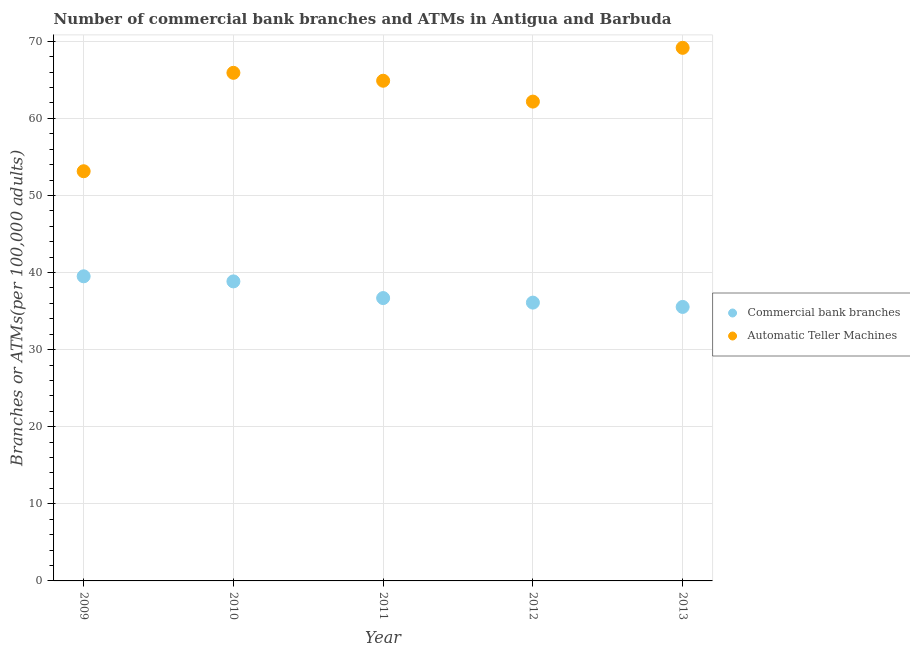How many different coloured dotlines are there?
Give a very brief answer. 2. Is the number of dotlines equal to the number of legend labels?
Offer a terse response. Yes. What is the number of commercal bank branches in 2010?
Offer a very short reply. 38.85. Across all years, what is the maximum number of atms?
Provide a short and direct response. 69.15. Across all years, what is the minimum number of atms?
Your answer should be very brief. 53.14. In which year was the number of atms maximum?
Your answer should be very brief. 2013. In which year was the number of atms minimum?
Your answer should be compact. 2009. What is the total number of commercal bank branches in the graph?
Keep it short and to the point. 186.69. What is the difference between the number of atms in 2009 and that in 2010?
Give a very brief answer. -12.76. What is the difference between the number of atms in 2011 and the number of commercal bank branches in 2010?
Make the answer very short. 26.03. What is the average number of atms per year?
Provide a short and direct response. 63.05. In the year 2013, what is the difference between the number of atms and number of commercal bank branches?
Your response must be concise. 33.61. What is the ratio of the number of commercal bank branches in 2011 to that in 2012?
Make the answer very short. 1.02. Is the difference between the number of atms in 2012 and 2013 greater than the difference between the number of commercal bank branches in 2012 and 2013?
Your response must be concise. No. What is the difference between the highest and the second highest number of atms?
Keep it short and to the point. 3.24. What is the difference between the highest and the lowest number of commercal bank branches?
Give a very brief answer. 3.97. Is the number of commercal bank branches strictly greater than the number of atms over the years?
Offer a terse response. No. Is the number of atms strictly less than the number of commercal bank branches over the years?
Offer a very short reply. No. How many dotlines are there?
Provide a succinct answer. 2. How many years are there in the graph?
Your answer should be compact. 5. Does the graph contain any zero values?
Give a very brief answer. No. What is the title of the graph?
Ensure brevity in your answer.  Number of commercial bank branches and ATMs in Antigua and Barbuda. Does "Arms exports" appear as one of the legend labels in the graph?
Make the answer very short. No. What is the label or title of the X-axis?
Make the answer very short. Year. What is the label or title of the Y-axis?
Offer a very short reply. Branches or ATMs(per 100,0 adults). What is the Branches or ATMs(per 100,000 adults) in Commercial bank branches in 2009?
Keep it short and to the point. 39.51. What is the Branches or ATMs(per 100,000 adults) of Automatic Teller Machines in 2009?
Your answer should be very brief. 53.14. What is the Branches or ATMs(per 100,000 adults) of Commercial bank branches in 2010?
Give a very brief answer. 38.85. What is the Branches or ATMs(per 100,000 adults) in Automatic Teller Machines in 2010?
Make the answer very short. 65.91. What is the Branches or ATMs(per 100,000 adults) in Commercial bank branches in 2011?
Keep it short and to the point. 36.69. What is the Branches or ATMs(per 100,000 adults) in Automatic Teller Machines in 2011?
Your answer should be compact. 64.88. What is the Branches or ATMs(per 100,000 adults) in Commercial bank branches in 2012?
Your answer should be very brief. 36.1. What is the Branches or ATMs(per 100,000 adults) of Automatic Teller Machines in 2012?
Provide a short and direct response. 62.17. What is the Branches or ATMs(per 100,000 adults) of Commercial bank branches in 2013?
Keep it short and to the point. 35.54. What is the Branches or ATMs(per 100,000 adults) in Automatic Teller Machines in 2013?
Ensure brevity in your answer.  69.15. Across all years, what is the maximum Branches or ATMs(per 100,000 adults) in Commercial bank branches?
Offer a very short reply. 39.51. Across all years, what is the maximum Branches or ATMs(per 100,000 adults) of Automatic Teller Machines?
Your response must be concise. 69.15. Across all years, what is the minimum Branches or ATMs(per 100,000 adults) in Commercial bank branches?
Ensure brevity in your answer.  35.54. Across all years, what is the minimum Branches or ATMs(per 100,000 adults) of Automatic Teller Machines?
Your response must be concise. 53.14. What is the total Branches or ATMs(per 100,000 adults) in Commercial bank branches in the graph?
Provide a succinct answer. 186.69. What is the total Branches or ATMs(per 100,000 adults) of Automatic Teller Machines in the graph?
Give a very brief answer. 315.24. What is the difference between the Branches or ATMs(per 100,000 adults) of Commercial bank branches in 2009 and that in 2010?
Provide a succinct answer. 0.66. What is the difference between the Branches or ATMs(per 100,000 adults) of Automatic Teller Machines in 2009 and that in 2010?
Your answer should be compact. -12.76. What is the difference between the Branches or ATMs(per 100,000 adults) in Commercial bank branches in 2009 and that in 2011?
Provide a succinct answer. 2.82. What is the difference between the Branches or ATMs(per 100,000 adults) in Automatic Teller Machines in 2009 and that in 2011?
Offer a terse response. -11.74. What is the difference between the Branches or ATMs(per 100,000 adults) in Commercial bank branches in 2009 and that in 2012?
Your answer should be compact. 3.41. What is the difference between the Branches or ATMs(per 100,000 adults) in Automatic Teller Machines in 2009 and that in 2012?
Provide a succinct answer. -9.03. What is the difference between the Branches or ATMs(per 100,000 adults) in Commercial bank branches in 2009 and that in 2013?
Offer a very short reply. 3.97. What is the difference between the Branches or ATMs(per 100,000 adults) in Automatic Teller Machines in 2009 and that in 2013?
Give a very brief answer. -16.01. What is the difference between the Branches or ATMs(per 100,000 adults) in Commercial bank branches in 2010 and that in 2011?
Make the answer very short. 2.16. What is the difference between the Branches or ATMs(per 100,000 adults) in Automatic Teller Machines in 2010 and that in 2011?
Provide a short and direct response. 1.03. What is the difference between the Branches or ATMs(per 100,000 adults) of Commercial bank branches in 2010 and that in 2012?
Offer a terse response. 2.75. What is the difference between the Branches or ATMs(per 100,000 adults) in Automatic Teller Machines in 2010 and that in 2012?
Keep it short and to the point. 3.73. What is the difference between the Branches or ATMs(per 100,000 adults) in Commercial bank branches in 2010 and that in 2013?
Offer a terse response. 3.31. What is the difference between the Branches or ATMs(per 100,000 adults) of Automatic Teller Machines in 2010 and that in 2013?
Offer a very short reply. -3.24. What is the difference between the Branches or ATMs(per 100,000 adults) in Commercial bank branches in 2011 and that in 2012?
Your answer should be very brief. 0.59. What is the difference between the Branches or ATMs(per 100,000 adults) in Automatic Teller Machines in 2011 and that in 2012?
Keep it short and to the point. 2.71. What is the difference between the Branches or ATMs(per 100,000 adults) in Commercial bank branches in 2011 and that in 2013?
Your response must be concise. 1.15. What is the difference between the Branches or ATMs(per 100,000 adults) of Automatic Teller Machines in 2011 and that in 2013?
Offer a terse response. -4.27. What is the difference between the Branches or ATMs(per 100,000 adults) of Commercial bank branches in 2012 and that in 2013?
Provide a succinct answer. 0.56. What is the difference between the Branches or ATMs(per 100,000 adults) in Automatic Teller Machines in 2012 and that in 2013?
Your answer should be very brief. -6.97. What is the difference between the Branches or ATMs(per 100,000 adults) of Commercial bank branches in 2009 and the Branches or ATMs(per 100,000 adults) of Automatic Teller Machines in 2010?
Your answer should be compact. -26.39. What is the difference between the Branches or ATMs(per 100,000 adults) in Commercial bank branches in 2009 and the Branches or ATMs(per 100,000 adults) in Automatic Teller Machines in 2011?
Offer a terse response. -25.37. What is the difference between the Branches or ATMs(per 100,000 adults) in Commercial bank branches in 2009 and the Branches or ATMs(per 100,000 adults) in Automatic Teller Machines in 2012?
Your answer should be very brief. -22.66. What is the difference between the Branches or ATMs(per 100,000 adults) in Commercial bank branches in 2009 and the Branches or ATMs(per 100,000 adults) in Automatic Teller Machines in 2013?
Provide a short and direct response. -29.64. What is the difference between the Branches or ATMs(per 100,000 adults) of Commercial bank branches in 2010 and the Branches or ATMs(per 100,000 adults) of Automatic Teller Machines in 2011?
Your response must be concise. -26.03. What is the difference between the Branches or ATMs(per 100,000 adults) in Commercial bank branches in 2010 and the Branches or ATMs(per 100,000 adults) in Automatic Teller Machines in 2012?
Your answer should be compact. -23.32. What is the difference between the Branches or ATMs(per 100,000 adults) in Commercial bank branches in 2010 and the Branches or ATMs(per 100,000 adults) in Automatic Teller Machines in 2013?
Your response must be concise. -30.3. What is the difference between the Branches or ATMs(per 100,000 adults) in Commercial bank branches in 2011 and the Branches or ATMs(per 100,000 adults) in Automatic Teller Machines in 2012?
Provide a short and direct response. -25.48. What is the difference between the Branches or ATMs(per 100,000 adults) of Commercial bank branches in 2011 and the Branches or ATMs(per 100,000 adults) of Automatic Teller Machines in 2013?
Offer a very short reply. -32.46. What is the difference between the Branches or ATMs(per 100,000 adults) in Commercial bank branches in 2012 and the Branches or ATMs(per 100,000 adults) in Automatic Teller Machines in 2013?
Your response must be concise. -33.05. What is the average Branches or ATMs(per 100,000 adults) of Commercial bank branches per year?
Keep it short and to the point. 37.34. What is the average Branches or ATMs(per 100,000 adults) in Automatic Teller Machines per year?
Give a very brief answer. 63.05. In the year 2009, what is the difference between the Branches or ATMs(per 100,000 adults) of Commercial bank branches and Branches or ATMs(per 100,000 adults) of Automatic Teller Machines?
Offer a very short reply. -13.63. In the year 2010, what is the difference between the Branches or ATMs(per 100,000 adults) in Commercial bank branches and Branches or ATMs(per 100,000 adults) in Automatic Teller Machines?
Keep it short and to the point. -27.05. In the year 2011, what is the difference between the Branches or ATMs(per 100,000 adults) in Commercial bank branches and Branches or ATMs(per 100,000 adults) in Automatic Teller Machines?
Make the answer very short. -28.19. In the year 2012, what is the difference between the Branches or ATMs(per 100,000 adults) in Commercial bank branches and Branches or ATMs(per 100,000 adults) in Automatic Teller Machines?
Your answer should be compact. -26.07. In the year 2013, what is the difference between the Branches or ATMs(per 100,000 adults) in Commercial bank branches and Branches or ATMs(per 100,000 adults) in Automatic Teller Machines?
Offer a terse response. -33.61. What is the ratio of the Branches or ATMs(per 100,000 adults) in Automatic Teller Machines in 2009 to that in 2010?
Make the answer very short. 0.81. What is the ratio of the Branches or ATMs(per 100,000 adults) of Automatic Teller Machines in 2009 to that in 2011?
Keep it short and to the point. 0.82. What is the ratio of the Branches or ATMs(per 100,000 adults) of Commercial bank branches in 2009 to that in 2012?
Your response must be concise. 1.09. What is the ratio of the Branches or ATMs(per 100,000 adults) of Automatic Teller Machines in 2009 to that in 2012?
Give a very brief answer. 0.85. What is the ratio of the Branches or ATMs(per 100,000 adults) in Commercial bank branches in 2009 to that in 2013?
Make the answer very short. 1.11. What is the ratio of the Branches or ATMs(per 100,000 adults) of Automatic Teller Machines in 2009 to that in 2013?
Provide a succinct answer. 0.77. What is the ratio of the Branches or ATMs(per 100,000 adults) of Commercial bank branches in 2010 to that in 2011?
Your answer should be compact. 1.06. What is the ratio of the Branches or ATMs(per 100,000 adults) of Automatic Teller Machines in 2010 to that in 2011?
Make the answer very short. 1.02. What is the ratio of the Branches or ATMs(per 100,000 adults) in Commercial bank branches in 2010 to that in 2012?
Offer a terse response. 1.08. What is the ratio of the Branches or ATMs(per 100,000 adults) of Automatic Teller Machines in 2010 to that in 2012?
Make the answer very short. 1.06. What is the ratio of the Branches or ATMs(per 100,000 adults) of Commercial bank branches in 2010 to that in 2013?
Ensure brevity in your answer.  1.09. What is the ratio of the Branches or ATMs(per 100,000 adults) of Automatic Teller Machines in 2010 to that in 2013?
Your answer should be compact. 0.95. What is the ratio of the Branches or ATMs(per 100,000 adults) in Commercial bank branches in 2011 to that in 2012?
Ensure brevity in your answer.  1.02. What is the ratio of the Branches or ATMs(per 100,000 adults) in Automatic Teller Machines in 2011 to that in 2012?
Keep it short and to the point. 1.04. What is the ratio of the Branches or ATMs(per 100,000 adults) of Commercial bank branches in 2011 to that in 2013?
Make the answer very short. 1.03. What is the ratio of the Branches or ATMs(per 100,000 adults) in Automatic Teller Machines in 2011 to that in 2013?
Your answer should be compact. 0.94. What is the ratio of the Branches or ATMs(per 100,000 adults) in Commercial bank branches in 2012 to that in 2013?
Keep it short and to the point. 1.02. What is the ratio of the Branches or ATMs(per 100,000 adults) of Automatic Teller Machines in 2012 to that in 2013?
Your answer should be very brief. 0.9. What is the difference between the highest and the second highest Branches or ATMs(per 100,000 adults) of Commercial bank branches?
Offer a very short reply. 0.66. What is the difference between the highest and the second highest Branches or ATMs(per 100,000 adults) of Automatic Teller Machines?
Make the answer very short. 3.24. What is the difference between the highest and the lowest Branches or ATMs(per 100,000 adults) of Commercial bank branches?
Your answer should be compact. 3.97. What is the difference between the highest and the lowest Branches or ATMs(per 100,000 adults) in Automatic Teller Machines?
Provide a short and direct response. 16.01. 